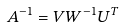Convert formula to latex. <formula><loc_0><loc_0><loc_500><loc_500>A ^ { - 1 } = V W ^ { - 1 } U ^ { T }</formula> 